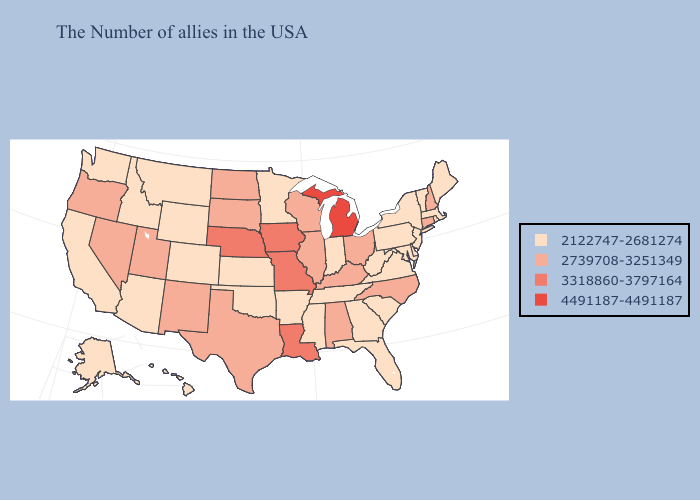Does Wyoming have a higher value than Washington?
Answer briefly. No. What is the value of Nebraska?
Short answer required. 3318860-3797164. Does New Mexico have a higher value than Illinois?
Concise answer only. No. Name the states that have a value in the range 3318860-3797164?
Give a very brief answer. Louisiana, Missouri, Iowa, Nebraska. What is the value of Alaska?
Quick response, please. 2122747-2681274. Does Colorado have the lowest value in the West?
Answer briefly. Yes. What is the value of Virginia?
Keep it brief. 2122747-2681274. Among the states that border Oklahoma , which have the highest value?
Give a very brief answer. Missouri. What is the value of Louisiana?
Answer briefly. 3318860-3797164. Which states have the lowest value in the MidWest?
Give a very brief answer. Indiana, Minnesota, Kansas. Among the states that border Texas , which have the highest value?
Concise answer only. Louisiana. Does Vermont have the lowest value in the USA?
Concise answer only. Yes. Does Alabama have the lowest value in the South?
Concise answer only. No. What is the value of Tennessee?
Write a very short answer. 2122747-2681274. What is the lowest value in the West?
Give a very brief answer. 2122747-2681274. 